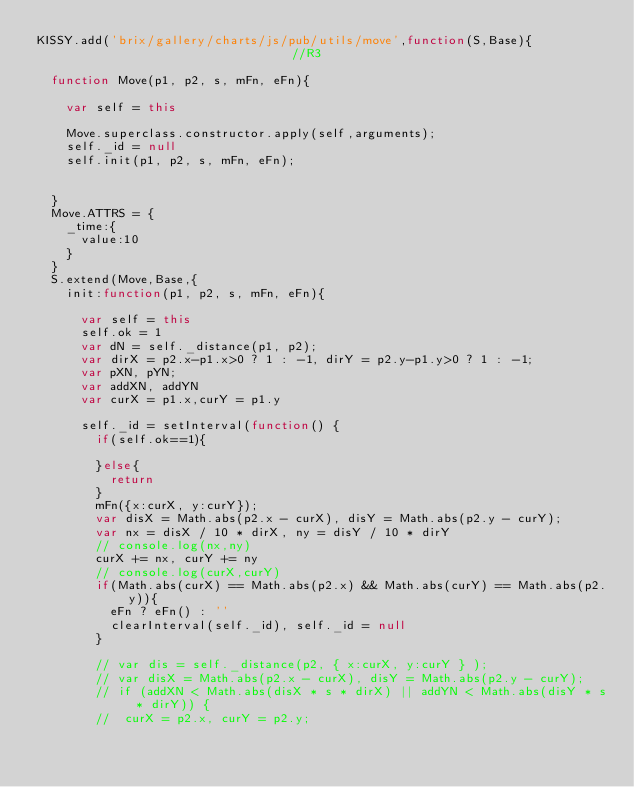<code> <loc_0><loc_0><loc_500><loc_500><_JavaScript_>KISSY.add('brix/gallery/charts/js/pub/utils/move',function(S,Base){                               //R3
	
	function Move(p1, p2, s, mFn, eFn){
		
		var self = this

		Move.superclass.constructor.apply(self,arguments);
		self._id = null
		self.init(p1, p2, s, mFn, eFn);


	}
	Move.ATTRS = {
		_time:{
			value:10
		}
	}
	S.extend(Move,Base,{
		init:function(p1, p2, s, mFn, eFn){
			
			var self = this
			self.ok = 1
			var dN = self._distance(p1, p2);
			var dirX = p2.x-p1.x>0 ? 1 : -1, dirY = p2.y-p1.y>0 ? 1 : -1;
			var pXN, pYN;
			var addXN, addYN
			var curX = p1.x,curY = p1.y
			
			self._id = setInterval(function() {
				if(self.ok==1){
					
				}else{
					return
				}
				mFn({x:curX, y:curY});
				var disX = Math.abs(p2.x - curX), disY = Math.abs(p2.y - curY);
				var nx = disX / 10 * dirX, ny = disY / 10 * dirY
 				// console.log(nx,ny)
				curX += nx, curY += ny
				// console.log(curX,curY)
				if(Math.abs(curX) == Math.abs(p2.x) && Math.abs(curY) == Math.abs(p2.y)){
					eFn ? eFn() : ''
					clearInterval(self._id), self._id = null
				}

				// var dis = self._distance(p2, { x:curX, y:curY } );
				// var disX = Math.abs(p2.x - curX), disY = Math.abs(p2.y - curY);
				// if (addXN < Math.abs(disX * s * dirX) || addYN < Math.abs(disY * s * dirY)) {
				// 	curX = p2.x, curY = p2.y;</code> 